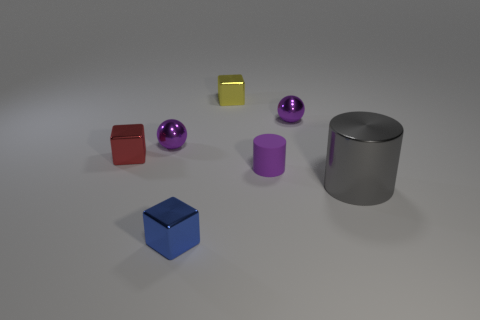Are there any other things that have the same size as the gray metallic cylinder?
Your answer should be compact. No. What number of cylinders are small gray things or tiny purple matte objects?
Offer a very short reply. 1. Does the tiny blue block have the same material as the small purple cylinder?
Ensure brevity in your answer.  No. How many other things are there of the same color as the tiny rubber object?
Offer a terse response. 2. What is the shape of the small purple thing that is on the left side of the tiny yellow shiny thing?
Give a very brief answer. Sphere. How many things are either purple matte cylinders or big rubber cylinders?
Your answer should be very brief. 1. Is the size of the purple matte object the same as the block that is in front of the gray metal object?
Give a very brief answer. Yes. What number of other objects are there of the same material as the large cylinder?
Keep it short and to the point. 5. What number of things are objects that are behind the gray metal thing or tiny things in front of the gray cylinder?
Provide a succinct answer. 6. There is a small object that is the same shape as the big gray metallic thing; what material is it?
Provide a short and direct response. Rubber. 